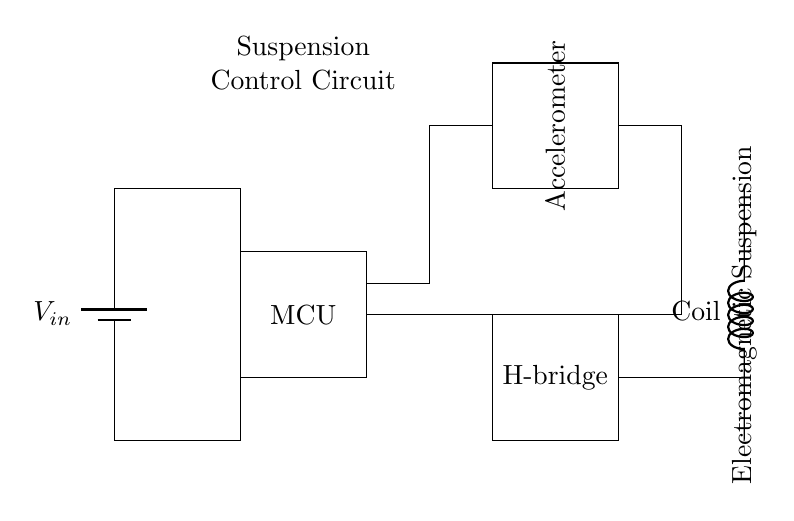What is the main component controlling the suspension? The main component is the microcontroller, which processes the information from the accelerometer to manage the suspension system.
Answer: Microcontroller What type of sensor is used in this circuit? The circuit uses an accelerometer, which measures changes in velocity to help adjust the suspension settings.
Answer: Accelerometer How many main components are in this circuit? There are four main components in the circuit: power supply, microcontroller, accelerometer, and H-bridge.
Answer: Four What is the role of the H-bridge in the circuit? The H-bridge controls the direction of the current flowing to the electromagnetic coil, allowing for dynamic adjustment of the suspension.
Answer: Direction control Which component is responsible for generating the electromagnetic force? The electromagnetic coil is responsible for generating the electromagnetic force used to improve shock absorption in the suspension.
Answer: Coil What is the purpose of the power supply in this circuit? The power supply provides the necessary voltage to operate all components of the suspension control circuit, ensuring they function correctly.
Answer: Voltage supply What happens to the circuit when the accelerometer detects a sudden change? The microcontroller processes the data from the accelerometer and adjusts the H-bridge to modify the electromagnetic coil's operation, improving suspension response.
Answer: Suspension adjustment 